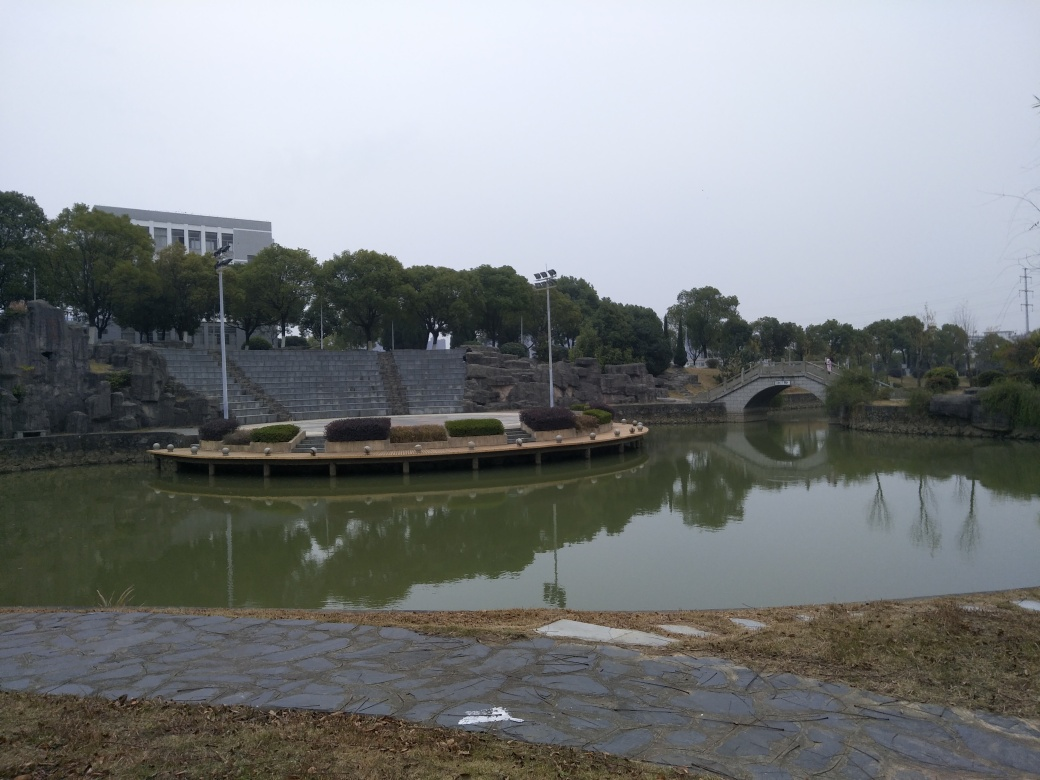Is the composition good? The composition is modestly engaging, with a balanced arrangement of elements, such as the reflection of the trees and bridge in the water providing symmetry. However, the grey sky and the subdued colors contribute to a lack of visual impact, which might be why the composition isn't considered outstanding. Furthermore, the foreground is somewhat cluttered and distracts from the central elements like the bridge and the pond platform. 